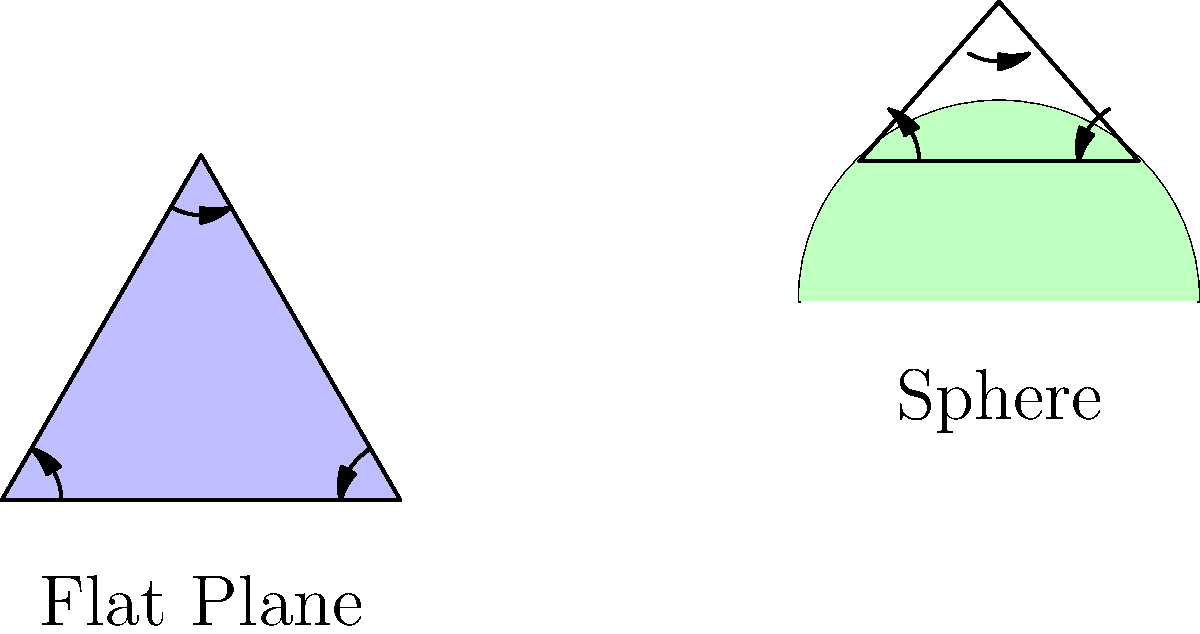In the context of Non-Euclidean Geometry, compare the sum of interior angles in a triangle on a flat plane versus a sphere. How does this difference impact the application of geometric principles in real-world scenarios, such as GPS navigation or property boundary disputes? 1. Flat Plane (Euclidean Geometry):
   - In Euclidean geometry, the sum of interior angles of a triangle is always 180°.
   - This is represented by the formula: $\sum \text{angles} = 180°$

2. Spherical Surface (Non-Euclidean Geometry):
   - On a sphere, the sum of interior angles of a triangle is always greater than 180°.
   - The formula for a spherical triangle is: $\sum \text{angles} = 180° + A$
     where $A$ is the area of the triangle on the sphere's surface.

3. Key Differences:
   - As the size of the triangle on a sphere increases, the sum of its angles also increases.
   - The "excess" angle (above 180°) is proportional to the triangle's area on the sphere.

4. Real-world Applications:
   a) GPS Navigation:
      - Earth is approximately spherical, so large-scale navigation must account for spherical geometry.
      - GPS systems use non-Euclidean calculations to accurately determine positions and distances.

   b) Property Boundary Disputes:
      - For small areas, Euclidean geometry is usually sufficient.
      - For large properties or across significant distances, spherical geometry becomes relevant.
      - Surveyors must consider the Earth's curvature for precise measurements.

5. Legal Implications:
   - In property law, understanding these geometric differences is crucial for accurately defining boundaries, especially for large territories or maritime borders.
   - Contracts or regulations involving large-scale measurements (e.g., international waters, air space) must account for non-Euclidean principles.

6. Gaming and Virtual Worlds:
   - Game developers creating large, realistic world maps need to consider spherical geometry for accurate navigation and distance calculations.
   - Some games intentionally use non-Euclidean geometry to create unique spatial experiences.

Understanding these geometric principles is essential for legal professionals dealing with cases involving large-scale measurements, international borders, or disputes related to GPS technology and mapping.
Answer: Flat plane triangle: sum of angles = 180°. Spherical triangle: sum of angles > 180°. Impacts large-scale navigation, boundary definitions, and legal disputes involving significant distances or areas. 